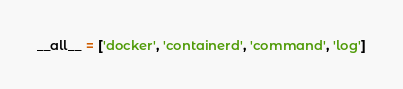Convert code to text. <code><loc_0><loc_0><loc_500><loc_500><_Python_>__all__ = ['docker', 'containerd', 'command', 'log']
</code> 